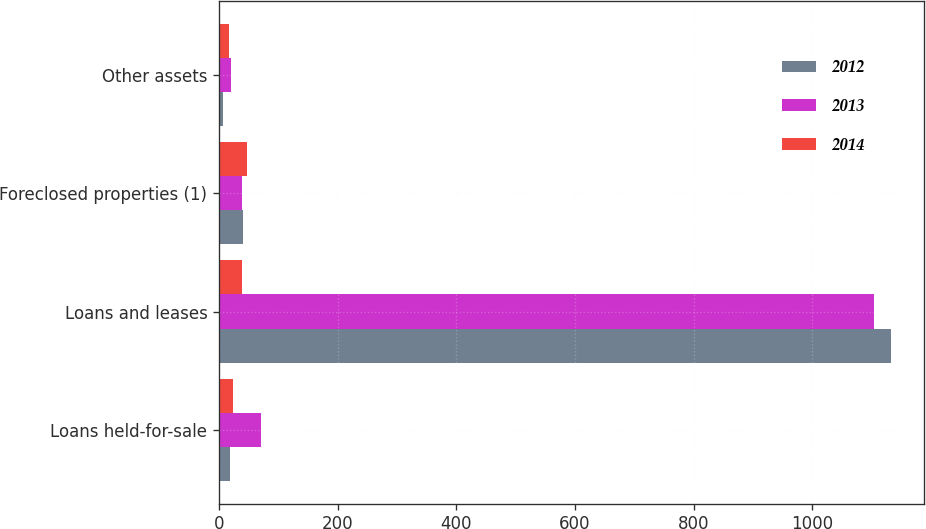<chart> <loc_0><loc_0><loc_500><loc_500><stacked_bar_chart><ecel><fcel>Loans held-for-sale<fcel>Loans and leases<fcel>Foreclosed properties (1)<fcel>Other assets<nl><fcel>2012<fcel>19<fcel>1132<fcel>40<fcel>6<nl><fcel>2013<fcel>71<fcel>1104<fcel>39<fcel>20<nl><fcel>2014<fcel>24<fcel>39<fcel>47<fcel>16<nl></chart> 